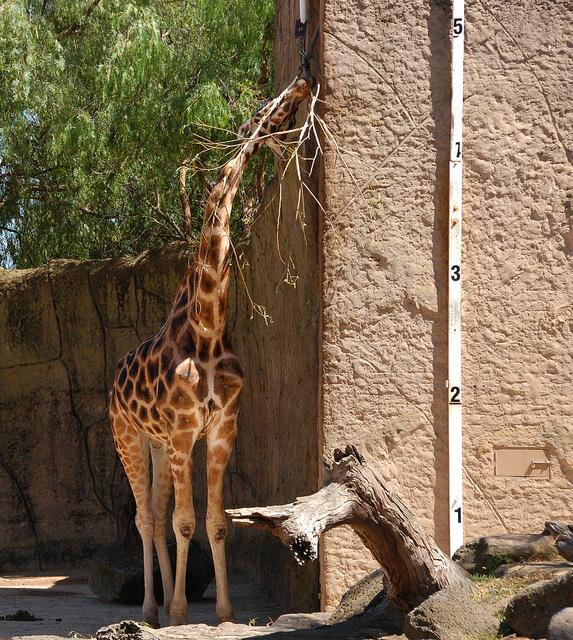What type of animal is this?
Short answer required. Giraffe. Is the giraffe trying to climb the wall?
Be succinct. No. What is the giraffe doing?
Write a very short answer. Eating. What is on the giraffes head?
Answer briefly. Nothing. Is this a zoo?
Write a very short answer. Yes. 